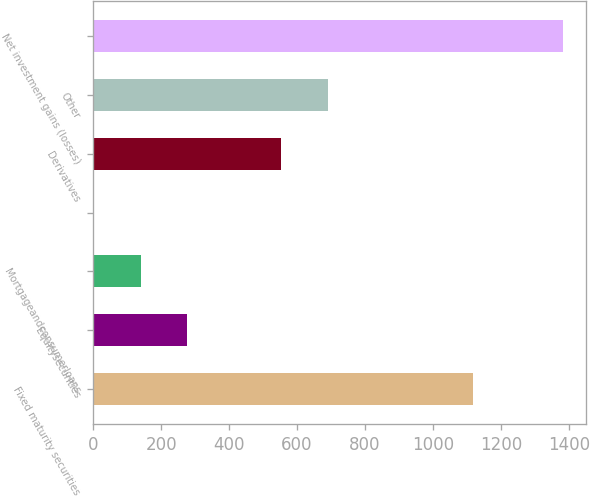Convert chart. <chart><loc_0><loc_0><loc_500><loc_500><bar_chart><fcel>Fixed maturity securities<fcel>Equitysecurities<fcel>Mortgageandconsumerloans<fcel>Unnamed: 3<fcel>Derivatives<fcel>Other<fcel>Net investment gains (losses)<nl><fcel>1119<fcel>277.2<fcel>139.1<fcel>1<fcel>553.4<fcel>691.5<fcel>1382<nl></chart> 